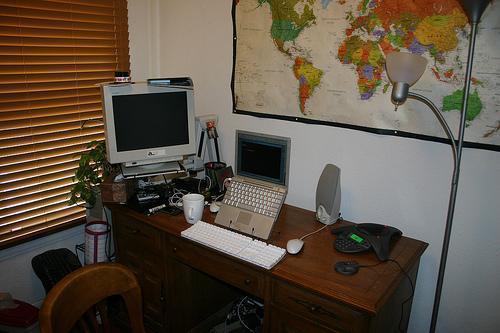How many keyboards are in the picture?
Give a very brief answer. 2. How many mugs are in the picture?
Give a very brief answer. 1. 